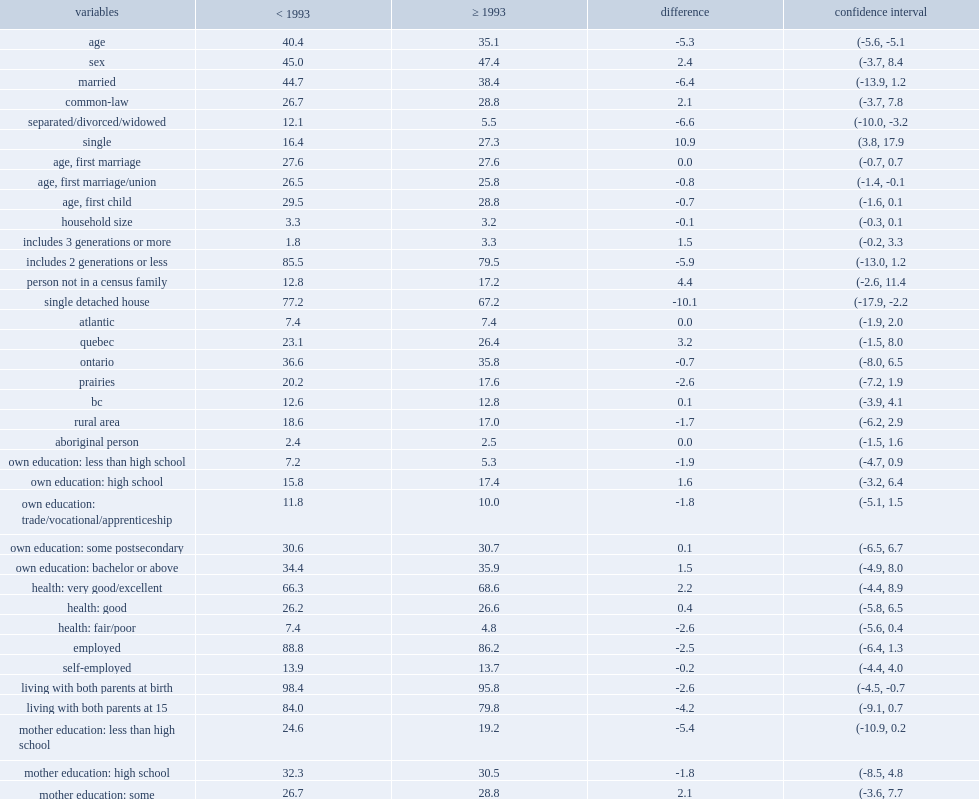What is the difference between link established before 1993 and linked in 1993 or after? 5.3. How many percent of people are more likely to live in a single detached home? 10.1. How many percent of those for whom a parent-child link was established before 1993 are less likely to report their mother as university-educated? 7.2. 